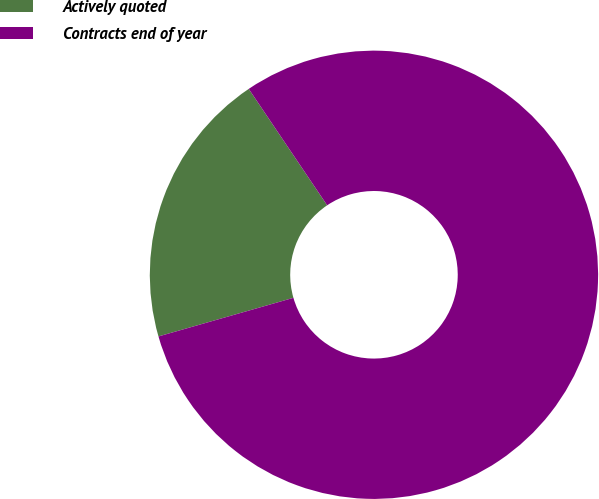Convert chart to OTSL. <chart><loc_0><loc_0><loc_500><loc_500><pie_chart><fcel>Actively quoted<fcel>Contracts end of year<nl><fcel>20.0%<fcel>80.0%<nl></chart> 